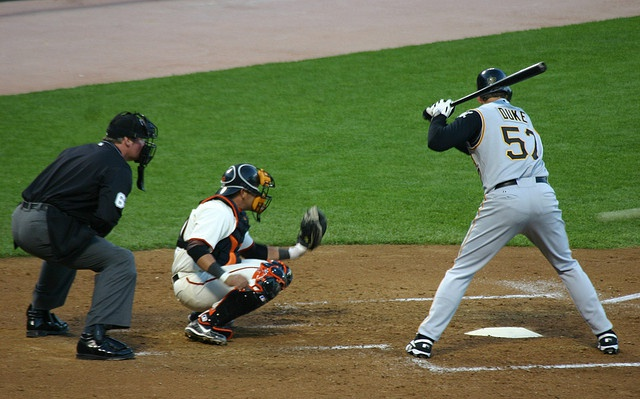Describe the objects in this image and their specific colors. I can see people in black, darkgray, and lightblue tones, people in black, purple, darkblue, and gray tones, people in black, white, gray, and darkgray tones, baseball glove in black, gray, darkgreen, and green tones, and baseball bat in black, gray, darkgray, and lightgray tones in this image. 